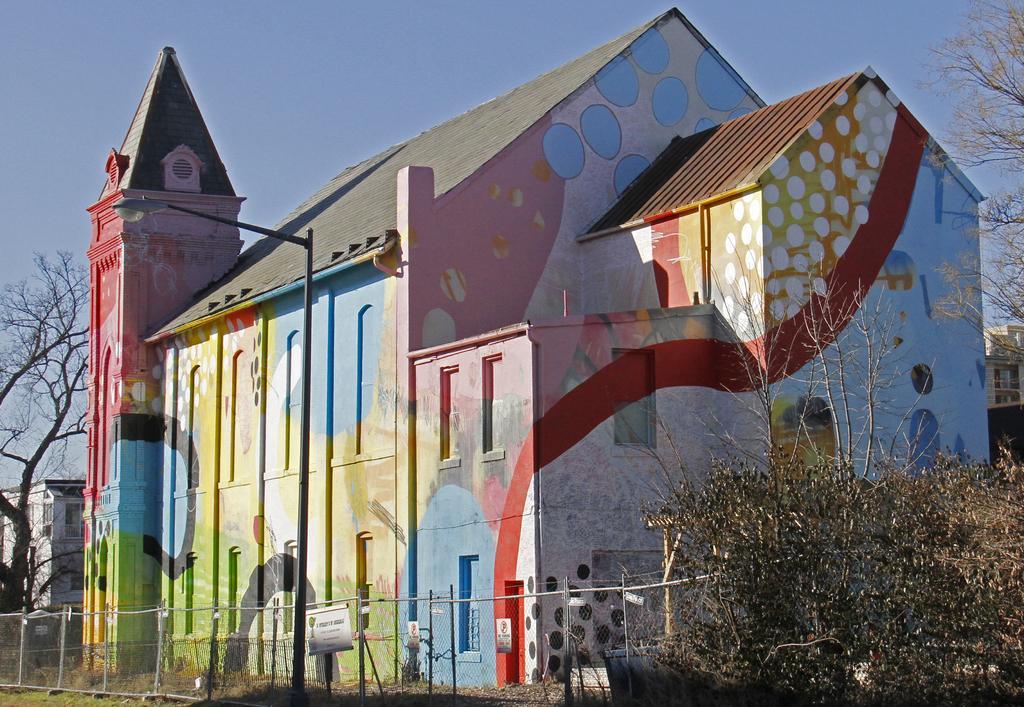Please provide a concise description of this image. In the image there is a house and in front of the house there are trees and behind the house there is a building and a tree. 